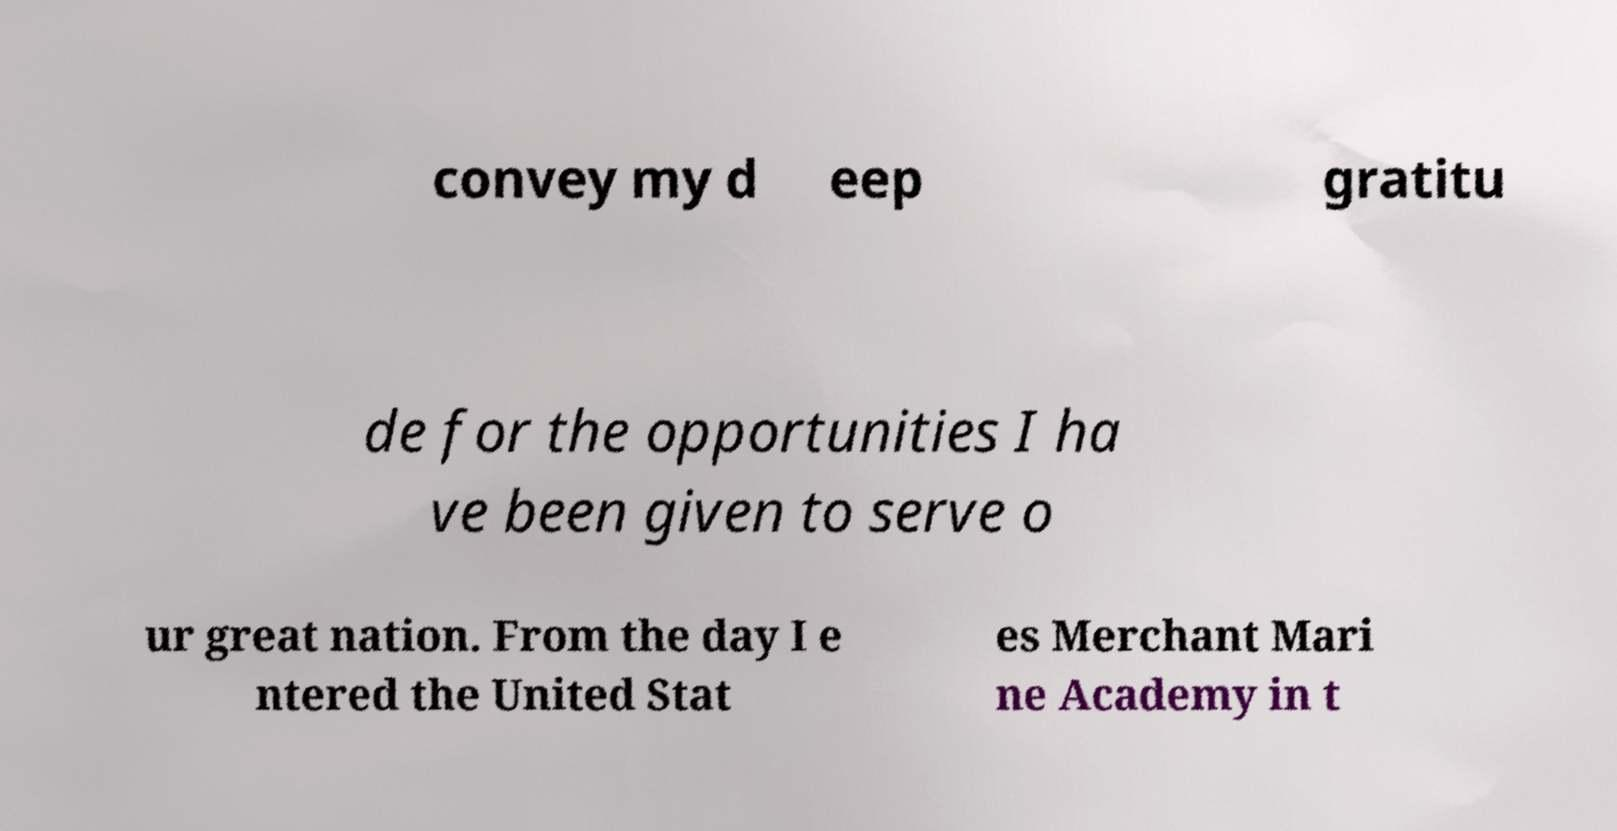Can you read and provide the text displayed in the image?This photo seems to have some interesting text. Can you extract and type it out for me? convey my d eep gratitu de for the opportunities I ha ve been given to serve o ur great nation. From the day I e ntered the United Stat es Merchant Mari ne Academy in t 